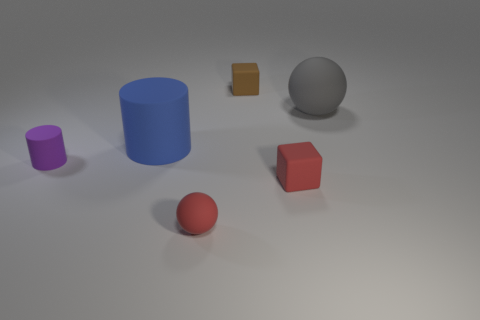If we were to guess, what time of day does the lighting suggest in this scene? The diffuse lighting with soft shadows might suggest it is either early morning or late afternoon, when the light is not too harsh and provides a soft glow to the objects. 